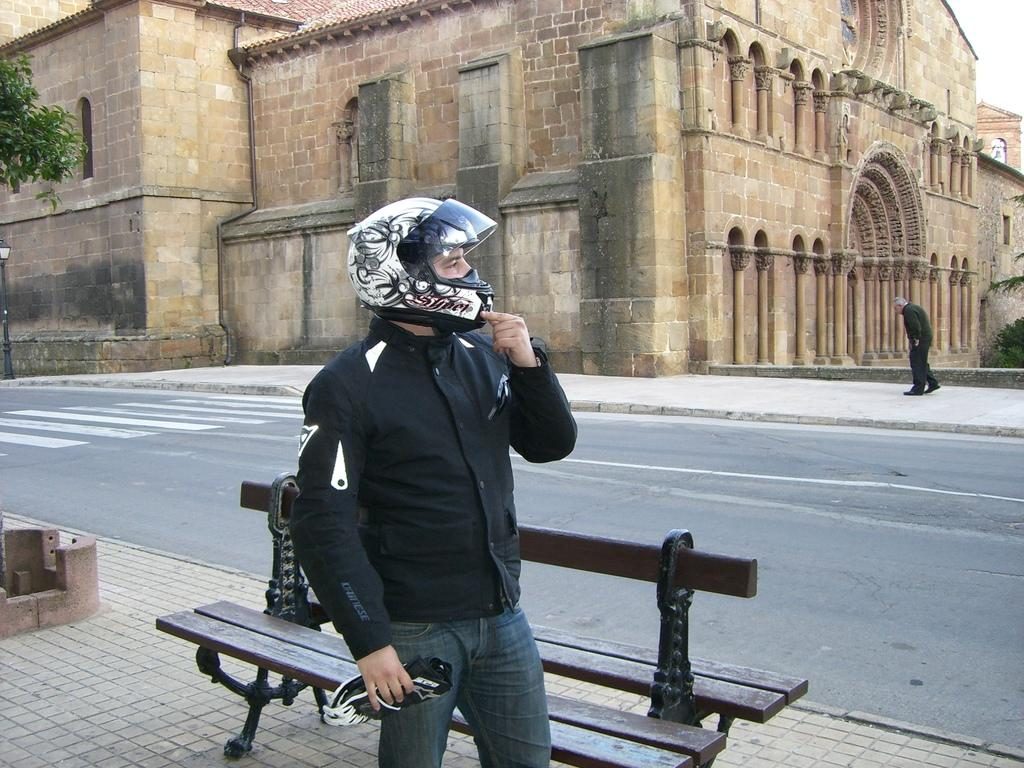What is the person in the image wearing on their head? The person in the image is wearing a helmet. What is located behind the person in the image? There is a bench behind the person in the image. What can be seen in the distance in the image? There is a road visible in the image, and a building can be seen in the background. What is the person in the image doing? A person is walking on a walkway in the image. What type of plant is growing on the person's chin in the image? There is no plant growing on the person's chin in the image. Is there a bat flying in the image? There is no bat visible in the image. 